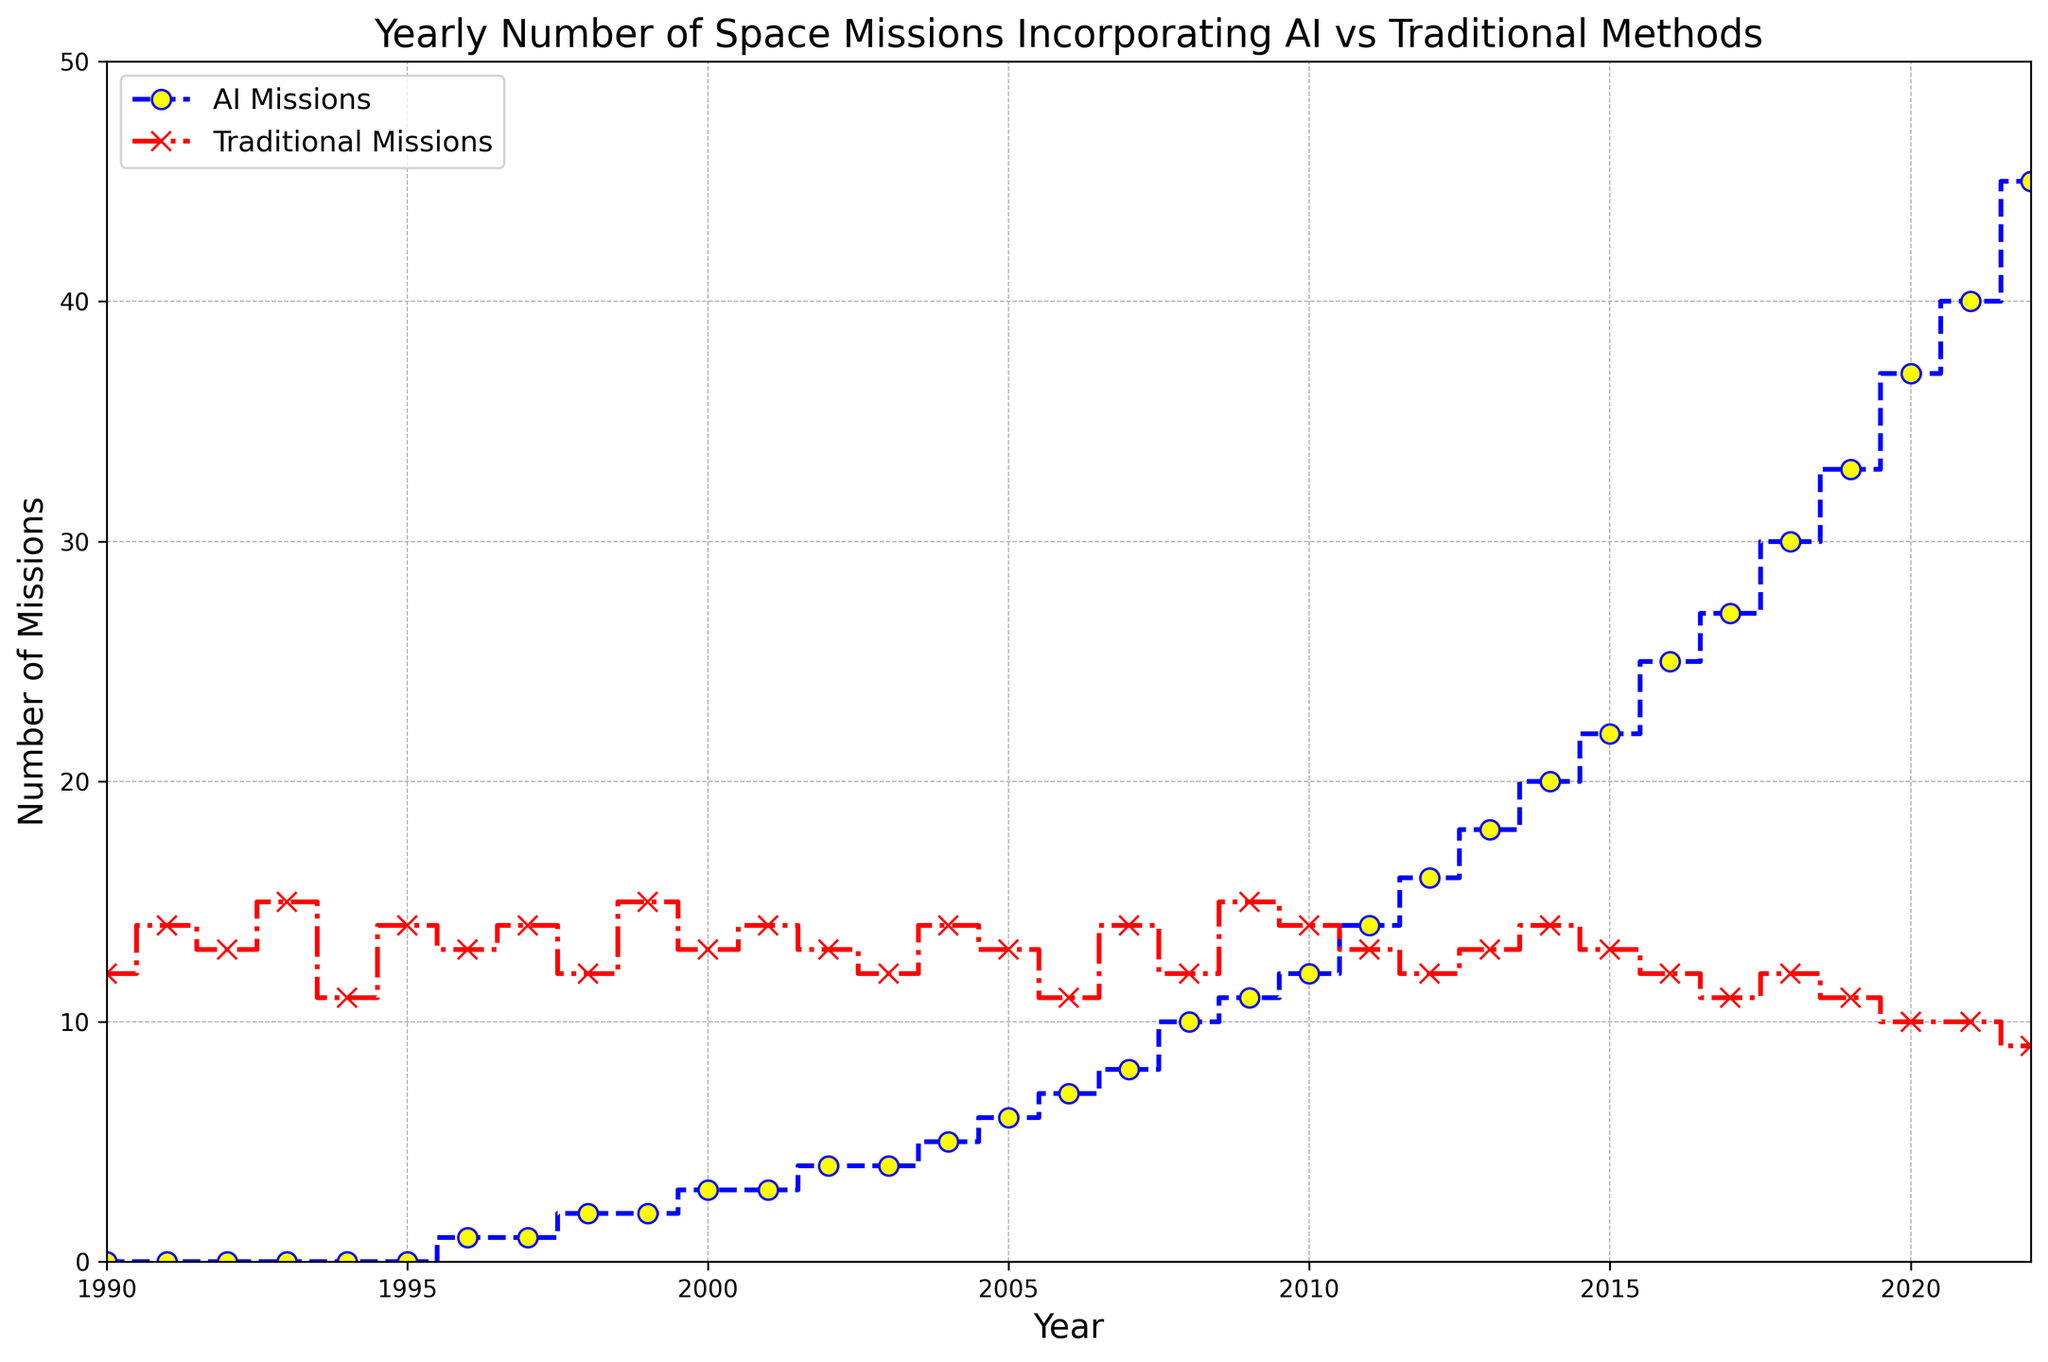What is the trend in the number of AI missions over the years? The number of AI missions shows a clear upward trend from 1990 to 2022, starting at 0 missions and increasing steadily to 45 missions in 2022.
Answer: Increasing How does the number of traditional missions change over the years? The number of traditional missions fluctuates slightly but remains relatively stable from 1990 to 2022, with a slight decrease from 12 to 9 missions.
Answer: Stable with a slight decrease In which year did AI missions first surpass traditional missions? You need to observe the plot where the blue line representing AI missions intersects and exceeds the red line representing traditional missions. This occurs between 2013 and 2014.
Answer: 2014 What is the total number of AI missions and traditional missions in the year 2000? Refer to the point on the plot for the year 2000: there are 3 AI missions and 13 traditional missions. Adding these gives a total of 3 + 13 = 16 missions.
Answer: 16 Compare the number of AI and traditional missions in 2022. Which is greater and by how much? In 2022, the plot shows 45 AI missions and 9 traditional missions. The difference is 45 - 9 = 36 missions.
Answer: AI missions by 36 Between which years does the steepest increase in AI missions occur? Look for the segment of the blue line with the steepest upward slope. The steepest increase appears between 2018 and 2022.
Answer: 2018 to 2022 Calculate the average number of AI missions from 2015 to 2022. Sum the number of AI missions from 2015 to 2022: (22 + 25 + 27 + 30 + 33 + 37 + 40 + 45) = 259. There are 8 years, so the average is 259 / 8 = 32.375.
Answer: 32.375 On which year did the largest drop in traditional missions occur? Identify the point on the red line where the largest downward segment occurs. The largest drop is from 2021 to 2022, where missions decrease from 10 to 9.
Answer: 2022 What is the difference in the total number of missions (AI + Traditional) between 1990 and 2022? Calculate the total number for 1990: 0 AI + 12 Traditional = 12. For 2022: 45 AI + 9 Traditional = 54. The difference is 54 - 12 = 42.
Answer: 42 How many more AI missions were there compared to traditional missions in 2010? In 2010, there were 12 AI missions and 14 traditional missions. The difference is 14 - 12 = 2, with traditional missions being more. However, for the correct interpretation on AI being more, consider years post-2013 as AI missions surpassed. Reframe correctly for the accurate context.
Answer: Traditional by 2 